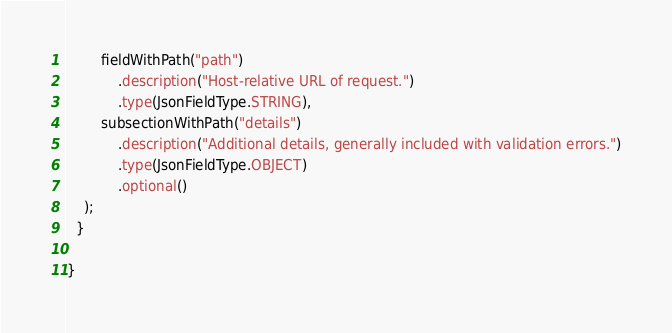Convert code to text. <code><loc_0><loc_0><loc_500><loc_500><_Java_>        fieldWithPath("path")
            .description("Host-relative URL of request.")
            .type(JsonFieldType.STRING),
        subsectionWithPath("details")
            .description("Additional details, generally included with validation errors.")
            .type(JsonFieldType.OBJECT)
            .optional()
    );
  }

}
</code> 